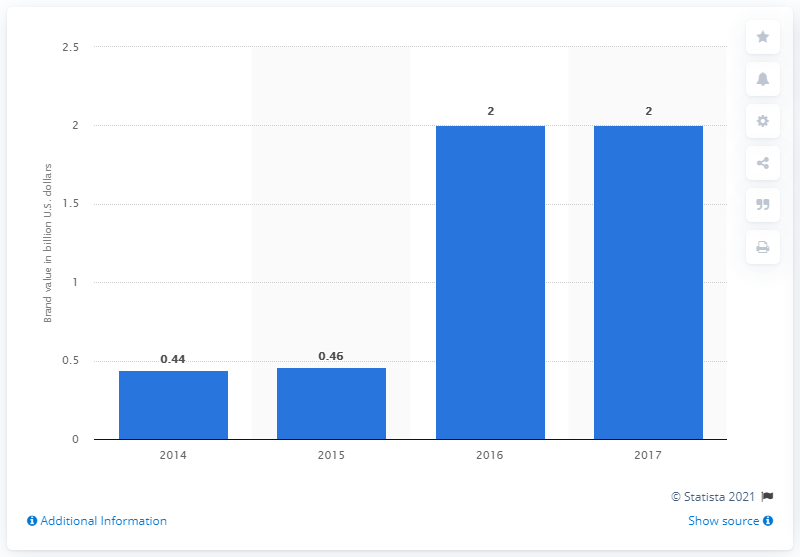Mention a couple of crucial points in this snapshot. In 2017, the brand value of the Ultimate Fighting Championship (UFC) was approximately $1.5 billion in United States dollars. 